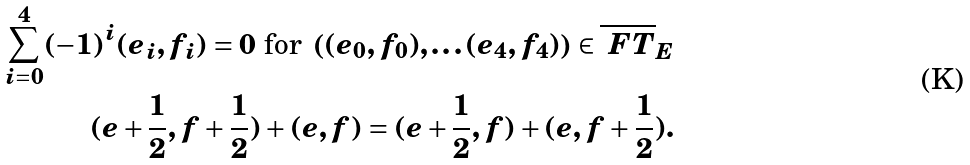<formula> <loc_0><loc_0><loc_500><loc_500>\sum _ { i = 0 } ^ { 4 } ( - 1 ) ^ { i } ( e _ { i } , f _ { i } ) = 0 \text { for } \left ( ( e _ { 0 } , f _ { 0 } ) , \dots ( e _ { 4 } , f _ { 4 } ) \right ) \in \overline { \ F T } _ { E } \\ ( e + \frac { 1 } { 2 } , f + \frac { 1 } { 2 } ) + ( e , f ) = ( e + \frac { 1 } { 2 } , f ) + ( e , f + \frac { 1 } { 2 } ) .</formula> 